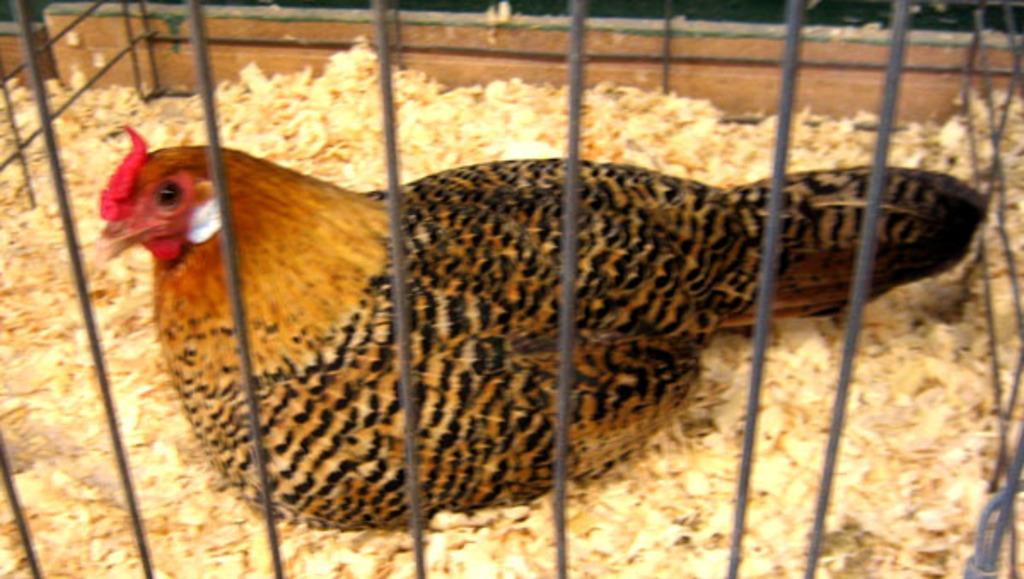What type of animal is in the image? There is a hen in the image. Where is the hen located? The hen is in a cage. What part of the hen is responsible for playing the guitar in the image? There is no guitar or indication of musical activity in the image; it only features a hen in a cage. 